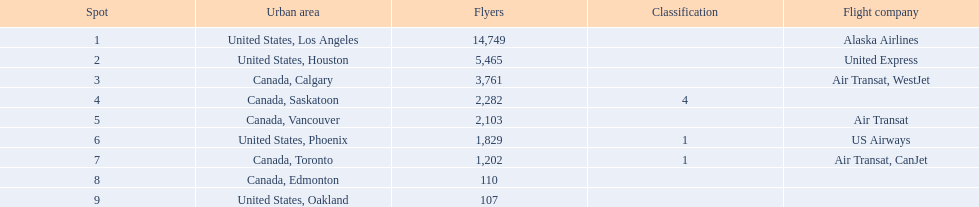Would you mind parsing the complete table? {'header': ['Spot', 'Urban area', 'Flyers', 'Classification', 'Flight company'], 'rows': [['1', 'United States, Los Angeles', '14,749', '', 'Alaska Airlines'], ['2', 'United States, Houston', '5,465', '', 'United Express'], ['3', 'Canada, Calgary', '3,761', '', 'Air Transat, WestJet'], ['4', 'Canada, Saskatoon', '2,282', '4', ''], ['5', 'Canada, Vancouver', '2,103', '', 'Air Transat'], ['6', 'United States, Phoenix', '1,829', '1', 'US Airways'], ['7', 'Canada, Toronto', '1,202', '1', 'Air Transat, CanJet'], ['8', 'Canada, Edmonton', '110', '', ''], ['9', 'United States, Oakland', '107', '', '']]} In addition to los angeles, which city also contributed to a combined passenger count of around 19,000? Canada, Calgary. 